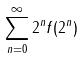Convert formula to latex. <formula><loc_0><loc_0><loc_500><loc_500>\sum _ { n = 0 } ^ { \infty } 2 ^ { n } f ( 2 ^ { n } )</formula> 